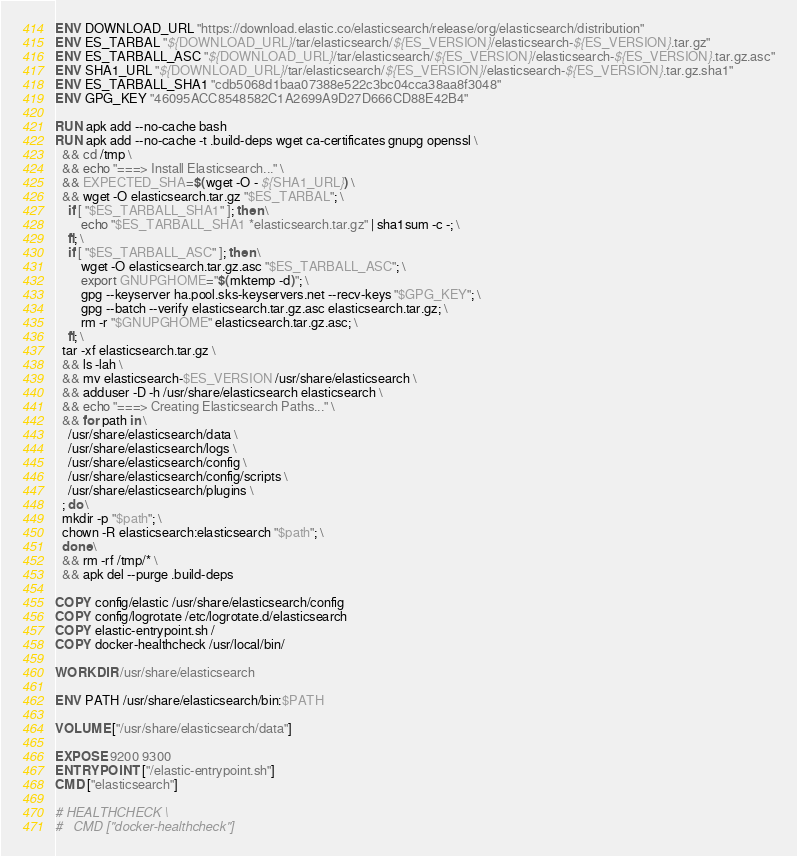Convert code to text. <code><loc_0><loc_0><loc_500><loc_500><_Dockerfile_>ENV DOWNLOAD_URL "https://download.elastic.co/elasticsearch/release/org/elasticsearch/distribution"
ENV ES_TARBAL "${DOWNLOAD_URL}/tar/elasticsearch/${ES_VERSION}/elasticsearch-${ES_VERSION}.tar.gz"
ENV ES_TARBALL_ASC "${DOWNLOAD_URL}/tar/elasticsearch/${ES_VERSION}/elasticsearch-${ES_VERSION}.tar.gz.asc"
ENV SHA1_URL "${DOWNLOAD_URL}/tar/elasticsearch/${ES_VERSION}/elasticsearch-${ES_VERSION}.tar.gz.sha1"
ENV ES_TARBALL_SHA1 "cdb5068d1baa07388e522c3bc04cca38aa8f3048"
ENV GPG_KEY "46095ACC8548582C1A2699A9D27D666CD88E42B4"

RUN apk add --no-cache bash
RUN apk add --no-cache -t .build-deps wget ca-certificates gnupg openssl \
  && cd /tmp \
  && echo "===> Install Elasticsearch..." \
  && EXPECTED_SHA=$(wget -O - ${SHA1_URL}) \
  && wget -O elasticsearch.tar.gz "$ES_TARBAL"; \
	if [ "$ES_TARBALL_SHA1" ]; then \
		echo "$ES_TARBALL_SHA1 *elasticsearch.tar.gz" | sha1sum -c -; \
	fi; \
	if [ "$ES_TARBALL_ASC" ]; then \
		wget -O elasticsearch.tar.gz.asc "$ES_TARBALL_ASC"; \
		export GNUPGHOME="$(mktemp -d)"; \
		gpg --keyserver ha.pool.sks-keyservers.net --recv-keys "$GPG_KEY"; \
		gpg --batch --verify elasticsearch.tar.gz.asc elasticsearch.tar.gz; \
		rm -r "$GNUPGHOME" elasticsearch.tar.gz.asc; \
	fi; \
  tar -xf elasticsearch.tar.gz \
  && ls -lah \
  && mv elasticsearch-$ES_VERSION /usr/share/elasticsearch \
  && adduser -D -h /usr/share/elasticsearch elasticsearch \
  && echo "===> Creating Elasticsearch Paths..." \
  && for path in \
  	/usr/share/elasticsearch/data \
  	/usr/share/elasticsearch/logs \
  	/usr/share/elasticsearch/config \
  	/usr/share/elasticsearch/config/scripts \
  	/usr/share/elasticsearch/plugins \
  ; do \
  mkdir -p "$path"; \
  chown -R elasticsearch:elasticsearch "$path"; \
  done \
  && rm -rf /tmp/* \
  && apk del --purge .build-deps

COPY config/elastic /usr/share/elasticsearch/config
COPY config/logrotate /etc/logrotate.d/elasticsearch
COPY elastic-entrypoint.sh /
COPY docker-healthcheck /usr/local/bin/

WORKDIR /usr/share/elasticsearch

ENV PATH /usr/share/elasticsearch/bin:$PATH

VOLUME ["/usr/share/elasticsearch/data"]

EXPOSE 9200 9300
ENTRYPOINT ["/elastic-entrypoint.sh"]
CMD ["elasticsearch"]

# HEALTHCHECK \
#   CMD ["docker-healthcheck"]
</code> 